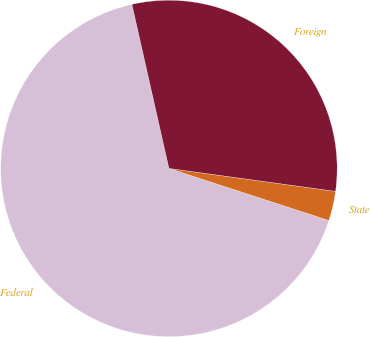<chart> <loc_0><loc_0><loc_500><loc_500><pie_chart><fcel>Federal<fcel>State<fcel>Foreign<nl><fcel>66.46%<fcel>2.83%<fcel>30.71%<nl></chart> 